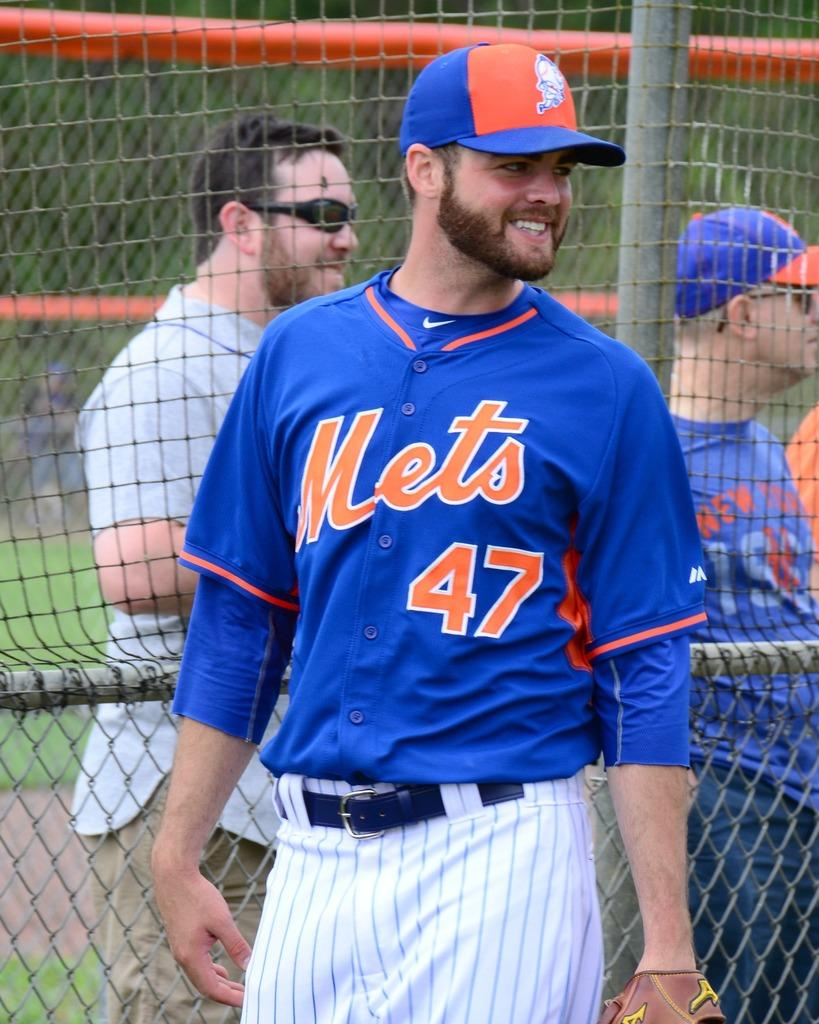<image>
Render a clear and concise summary of the photo. A guy wearing a blue Mets shirt with number 47 on it. 